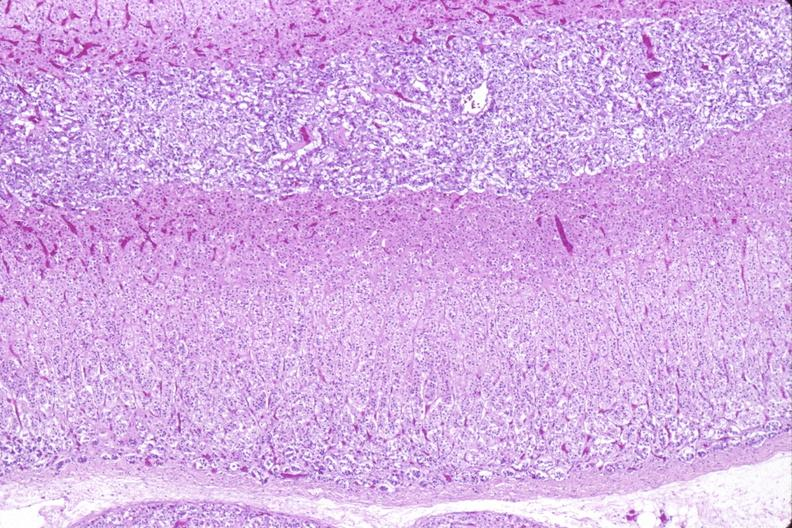does adenocarcinoma show adrenal gland, normal histology?
Answer the question using a single word or phrase. No 